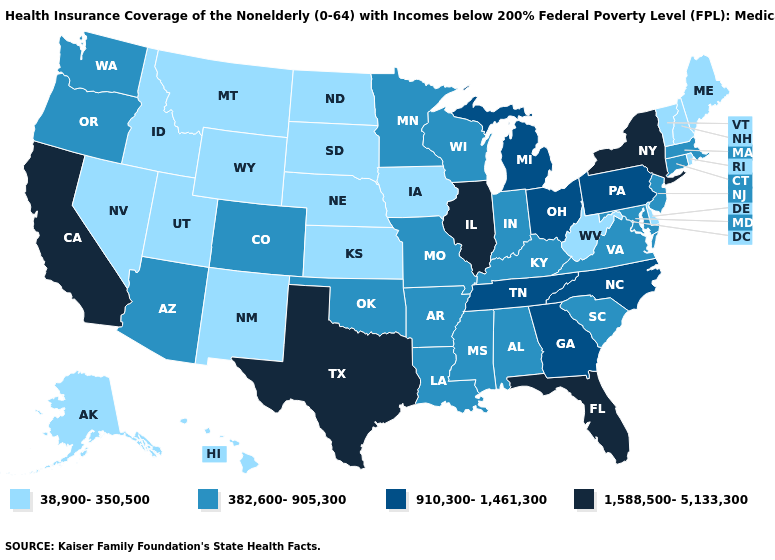Which states have the lowest value in the South?
Write a very short answer. Delaware, West Virginia. Which states have the lowest value in the USA?
Be succinct. Alaska, Delaware, Hawaii, Idaho, Iowa, Kansas, Maine, Montana, Nebraska, Nevada, New Hampshire, New Mexico, North Dakota, Rhode Island, South Dakota, Utah, Vermont, West Virginia, Wyoming. Does the first symbol in the legend represent the smallest category?
Be succinct. Yes. Name the states that have a value in the range 910,300-1,461,300?
Write a very short answer. Georgia, Michigan, North Carolina, Ohio, Pennsylvania, Tennessee. Does Washington have a lower value than Vermont?
Write a very short answer. No. Name the states that have a value in the range 1,588,500-5,133,300?
Answer briefly. California, Florida, Illinois, New York, Texas. What is the value of New Hampshire?
Answer briefly. 38,900-350,500. Does Ohio have a lower value than Hawaii?
Answer briefly. No. What is the lowest value in states that border Oregon?
Write a very short answer. 38,900-350,500. What is the value of New Jersey?
Answer briefly. 382,600-905,300. How many symbols are there in the legend?
Give a very brief answer. 4. Among the states that border Massachusetts , which have the lowest value?
Concise answer only. New Hampshire, Rhode Island, Vermont. Is the legend a continuous bar?
Keep it brief. No. Does Illinois have the highest value in the USA?
Be succinct. Yes. Name the states that have a value in the range 382,600-905,300?
Write a very short answer. Alabama, Arizona, Arkansas, Colorado, Connecticut, Indiana, Kentucky, Louisiana, Maryland, Massachusetts, Minnesota, Mississippi, Missouri, New Jersey, Oklahoma, Oregon, South Carolina, Virginia, Washington, Wisconsin. 